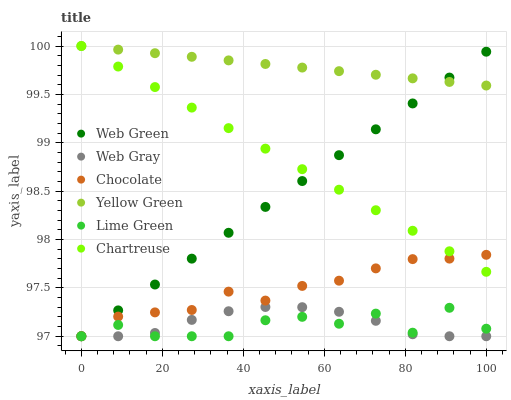Does Lime Green have the minimum area under the curve?
Answer yes or no. Yes. Does Yellow Green have the maximum area under the curve?
Answer yes or no. Yes. Does Web Green have the minimum area under the curve?
Answer yes or no. No. Does Web Green have the maximum area under the curve?
Answer yes or no. No. Is Yellow Green the smoothest?
Answer yes or no. Yes. Is Lime Green the roughest?
Answer yes or no. Yes. Is Web Green the smoothest?
Answer yes or no. No. Is Web Green the roughest?
Answer yes or no. No. Does Web Gray have the lowest value?
Answer yes or no. Yes. Does Yellow Green have the lowest value?
Answer yes or no. No. Does Chartreuse have the highest value?
Answer yes or no. Yes. Does Web Green have the highest value?
Answer yes or no. No. Is Web Gray less than Yellow Green?
Answer yes or no. Yes. Is Yellow Green greater than Chocolate?
Answer yes or no. Yes. Does Chocolate intersect Lime Green?
Answer yes or no. Yes. Is Chocolate less than Lime Green?
Answer yes or no. No. Is Chocolate greater than Lime Green?
Answer yes or no. No. Does Web Gray intersect Yellow Green?
Answer yes or no. No. 